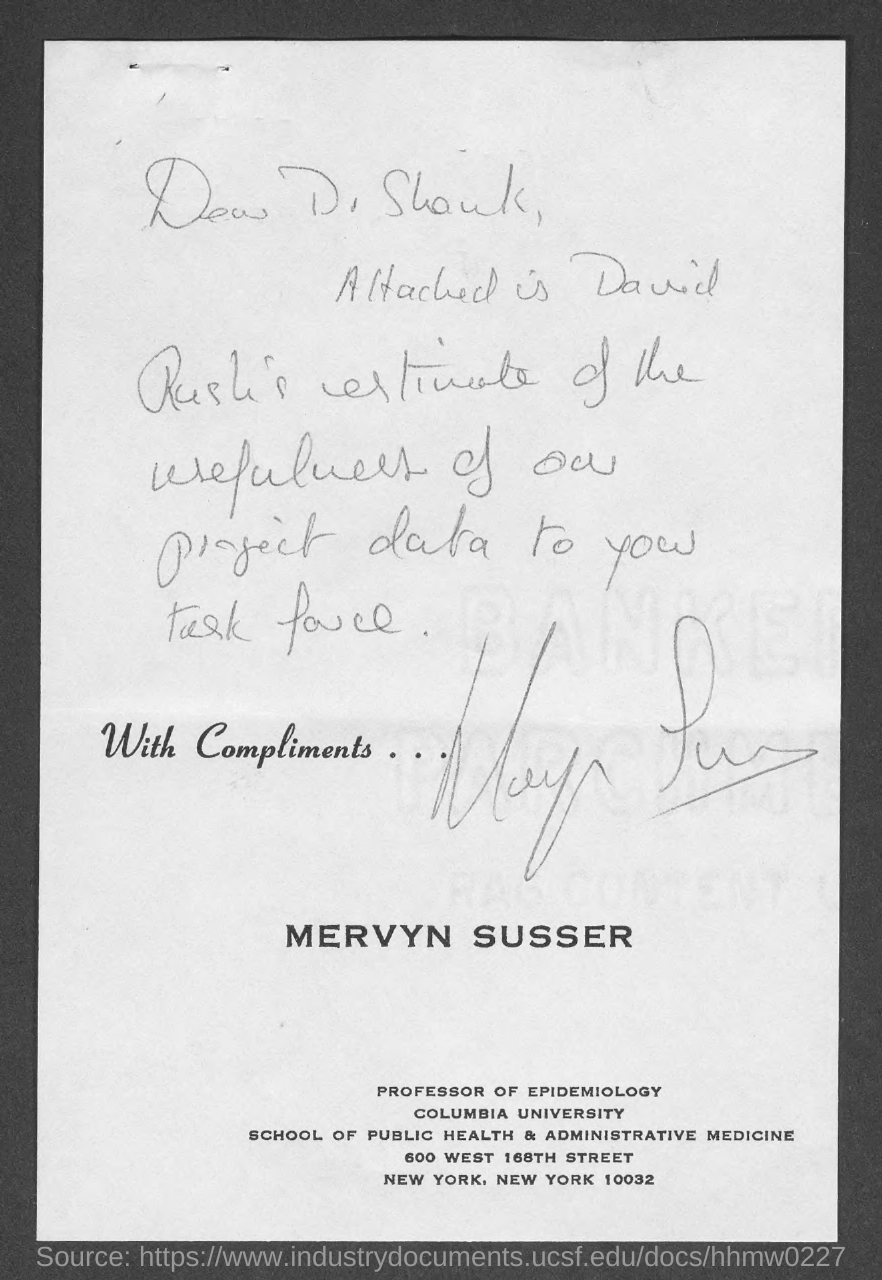Specify some key components in this picture. Mervyn SussER is a professor of epidemiology. The document has been signed by Mervyn Sussner. Mervyn Susser works at Columbia University. The document is addressed to Dr. Shank. 